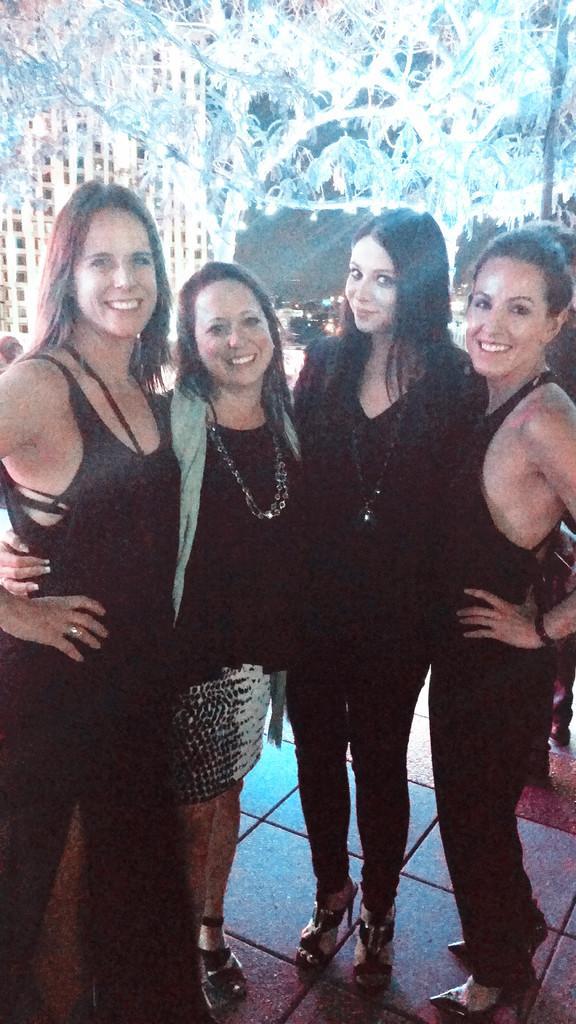Please provide a concise description of this image. In this image I can see there are four woman and they are smiling and they are standing on floor wearing black color dress and in the background I can see building and trees and lighting visible on tree. 